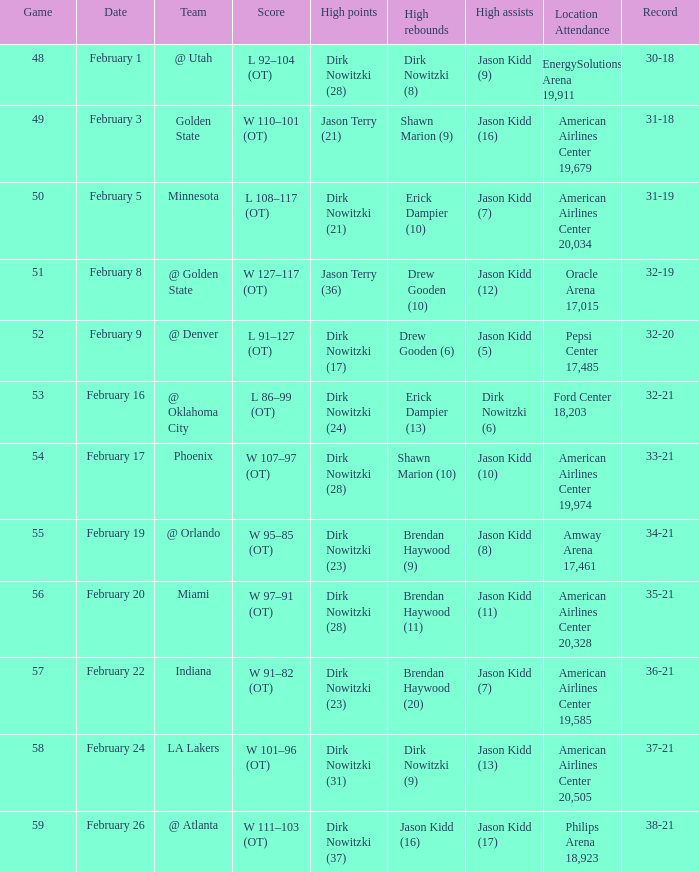Who had the most high assists with a record of 32-19? Jason Kidd (12). 